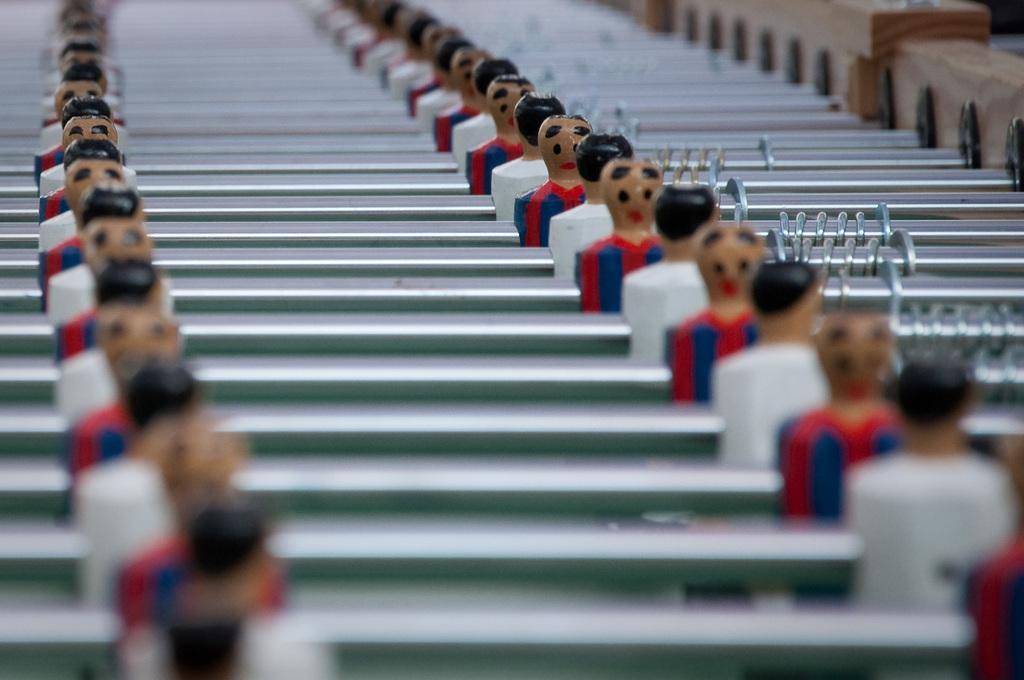In one or two sentences, can you explain what this image depicts? There are few toys which are white and red in color and there are rods beside them. 